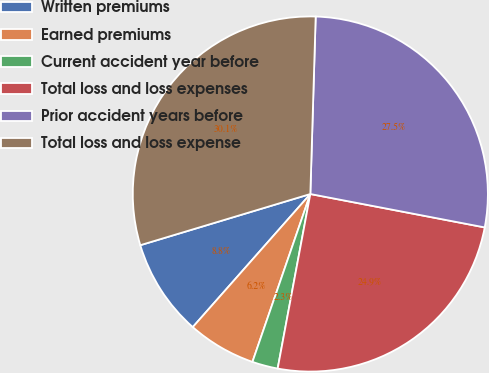<chart> <loc_0><loc_0><loc_500><loc_500><pie_chart><fcel>Written premiums<fcel>Earned premiums<fcel>Current accident year before<fcel>Total loss and loss expenses<fcel>Prior accident years before<fcel>Total loss and loss expense<nl><fcel>8.83%<fcel>6.23%<fcel>2.34%<fcel>24.93%<fcel>27.53%<fcel>30.13%<nl></chart> 